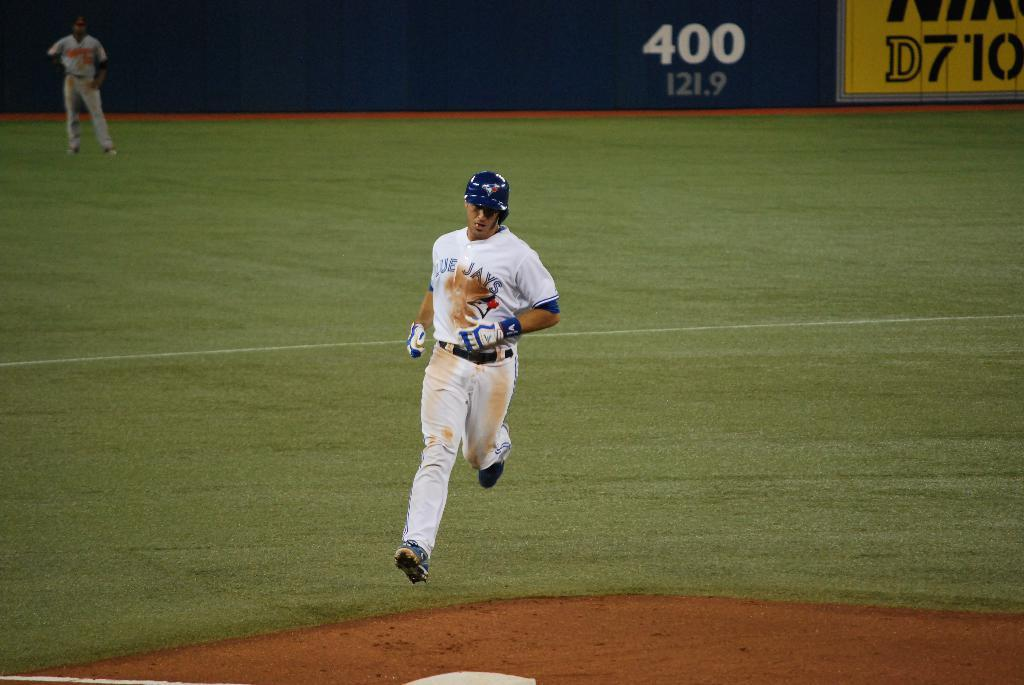<image>
Present a compact description of the photo's key features. Man playing for the Blue Jays running to base. 